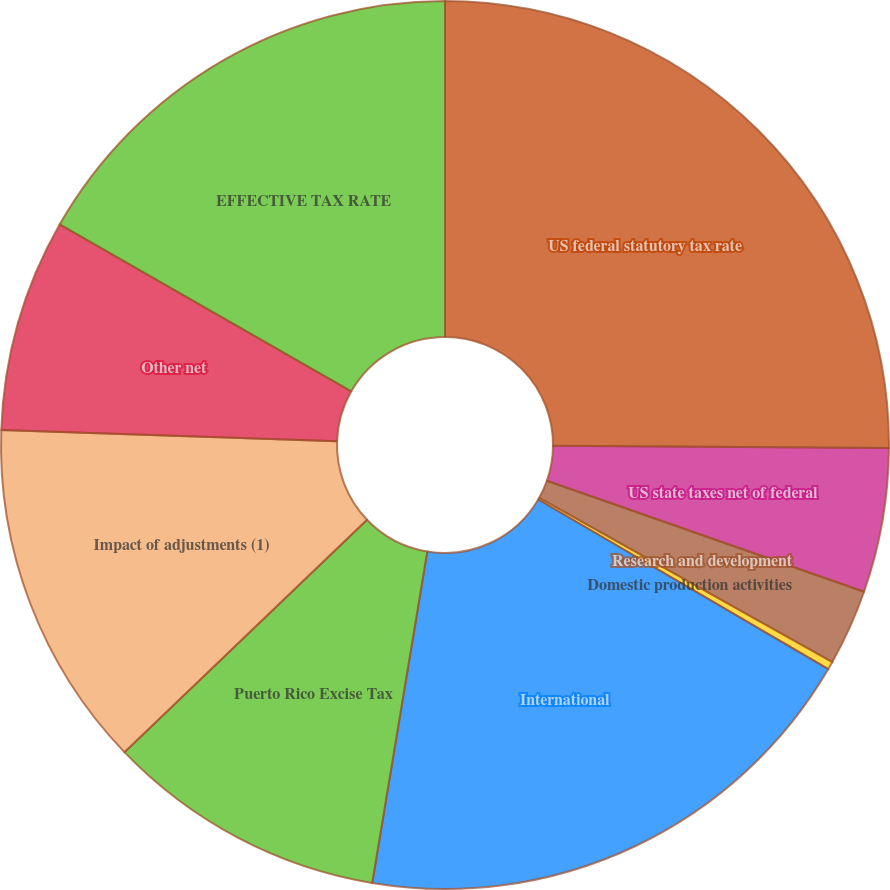<chart> <loc_0><loc_0><loc_500><loc_500><pie_chart><fcel>US federal statutory tax rate<fcel>US state taxes net of federal<fcel>Research and development<fcel>Domestic production activities<fcel>International<fcel>Puerto Rico Excise Tax<fcel>Impact of adjustments (1)<fcel>Other net<fcel>EFFECTIVE TAX RATE<nl><fcel>25.11%<fcel>5.25%<fcel>2.77%<fcel>0.29%<fcel>19.2%<fcel>10.22%<fcel>12.7%<fcel>7.74%<fcel>16.72%<nl></chart> 